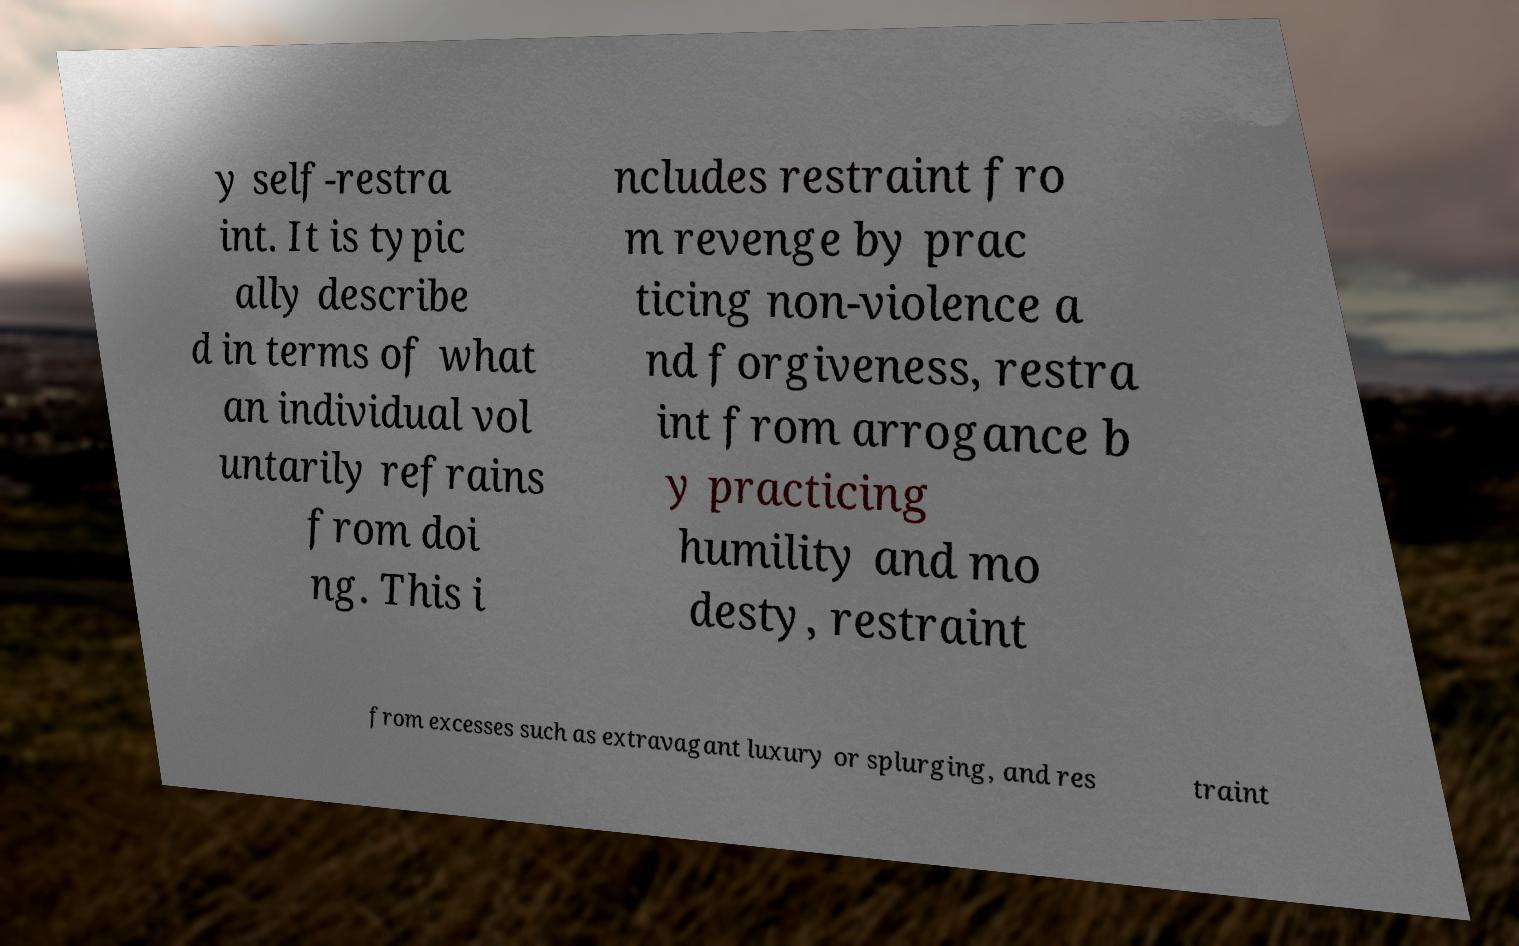Could you extract and type out the text from this image? y self-restra int. It is typic ally describe d in terms of what an individual vol untarily refrains from doi ng. This i ncludes restraint fro m revenge by prac ticing non-violence a nd forgiveness, restra int from arrogance b y practicing humility and mo desty, restraint from excesses such as extravagant luxury or splurging, and res traint 